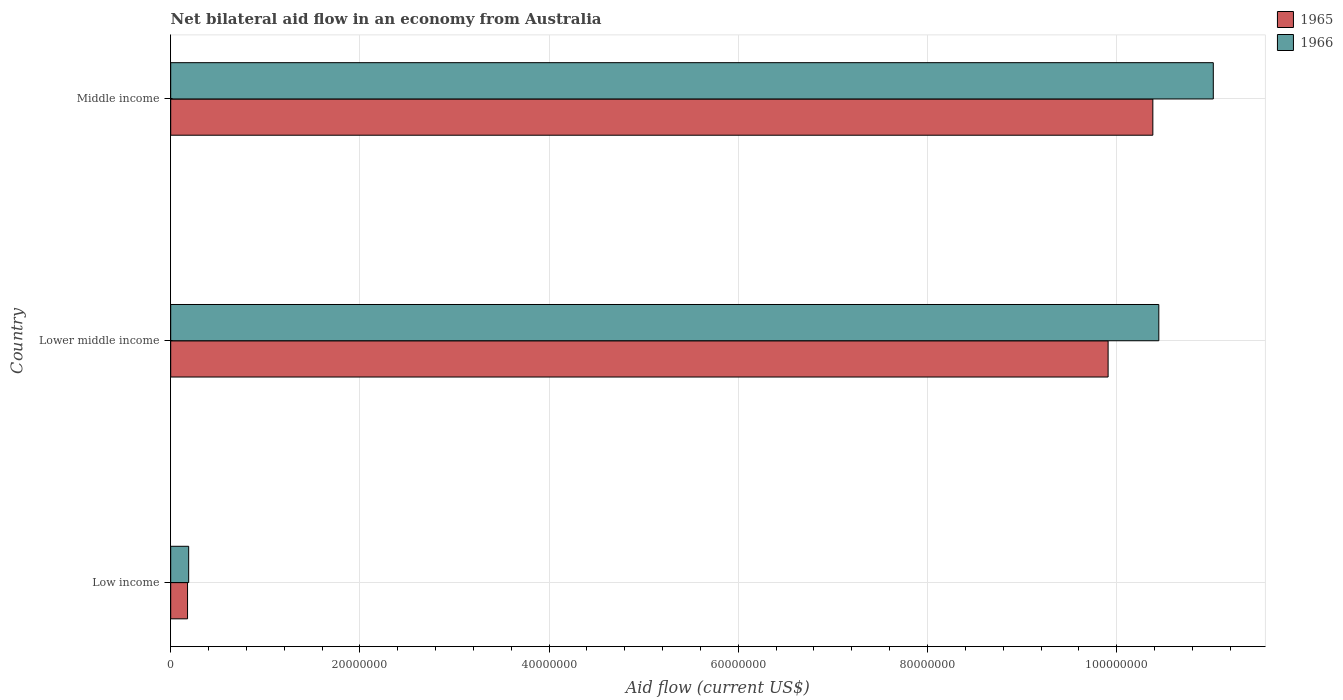How many different coloured bars are there?
Ensure brevity in your answer.  2. How many groups of bars are there?
Make the answer very short. 3. Are the number of bars on each tick of the Y-axis equal?
Make the answer very short. Yes. How many bars are there on the 3rd tick from the top?
Your response must be concise. 2. How many bars are there on the 3rd tick from the bottom?
Your response must be concise. 2. What is the label of the 3rd group of bars from the top?
Your answer should be compact. Low income. In how many cases, is the number of bars for a given country not equal to the number of legend labels?
Provide a succinct answer. 0. What is the net bilateral aid flow in 1965 in Low income?
Give a very brief answer. 1.78e+06. Across all countries, what is the maximum net bilateral aid flow in 1965?
Make the answer very short. 1.04e+08. Across all countries, what is the minimum net bilateral aid flow in 1965?
Provide a succinct answer. 1.78e+06. What is the total net bilateral aid flow in 1966 in the graph?
Your answer should be very brief. 2.17e+08. What is the difference between the net bilateral aid flow in 1965 in Low income and that in Lower middle income?
Give a very brief answer. -9.73e+07. What is the difference between the net bilateral aid flow in 1965 in Lower middle income and the net bilateral aid flow in 1966 in Middle income?
Offer a very short reply. -1.11e+07. What is the average net bilateral aid flow in 1966 per country?
Your response must be concise. 7.22e+07. What is the difference between the net bilateral aid flow in 1965 and net bilateral aid flow in 1966 in Middle income?
Give a very brief answer. -6.39e+06. What is the ratio of the net bilateral aid flow in 1966 in Lower middle income to that in Middle income?
Your answer should be compact. 0.95. Is the net bilateral aid flow in 1965 in Low income less than that in Lower middle income?
Your answer should be compact. Yes. What is the difference between the highest and the second highest net bilateral aid flow in 1965?
Ensure brevity in your answer.  4.73e+06. What is the difference between the highest and the lowest net bilateral aid flow in 1966?
Your response must be concise. 1.08e+08. In how many countries, is the net bilateral aid flow in 1966 greater than the average net bilateral aid flow in 1966 taken over all countries?
Offer a terse response. 2. Is the sum of the net bilateral aid flow in 1965 in Low income and Middle income greater than the maximum net bilateral aid flow in 1966 across all countries?
Provide a short and direct response. No. What does the 1st bar from the top in Middle income represents?
Offer a very short reply. 1966. What does the 2nd bar from the bottom in Low income represents?
Provide a short and direct response. 1966. How many countries are there in the graph?
Provide a short and direct response. 3. What is the difference between two consecutive major ticks on the X-axis?
Your answer should be very brief. 2.00e+07. Does the graph contain grids?
Ensure brevity in your answer.  Yes. Where does the legend appear in the graph?
Your answer should be compact. Top right. How many legend labels are there?
Provide a short and direct response. 2. How are the legend labels stacked?
Offer a very short reply. Vertical. What is the title of the graph?
Make the answer very short. Net bilateral aid flow in an economy from Australia. What is the label or title of the X-axis?
Provide a succinct answer. Aid flow (current US$). What is the label or title of the Y-axis?
Provide a succinct answer. Country. What is the Aid flow (current US$) in 1965 in Low income?
Provide a short and direct response. 1.78e+06. What is the Aid flow (current US$) in 1966 in Low income?
Give a very brief answer. 1.90e+06. What is the Aid flow (current US$) of 1965 in Lower middle income?
Keep it short and to the point. 9.91e+07. What is the Aid flow (current US$) of 1966 in Lower middle income?
Offer a very short reply. 1.04e+08. What is the Aid flow (current US$) of 1965 in Middle income?
Offer a terse response. 1.04e+08. What is the Aid flow (current US$) of 1966 in Middle income?
Give a very brief answer. 1.10e+08. Across all countries, what is the maximum Aid flow (current US$) in 1965?
Your answer should be compact. 1.04e+08. Across all countries, what is the maximum Aid flow (current US$) in 1966?
Your response must be concise. 1.10e+08. Across all countries, what is the minimum Aid flow (current US$) in 1965?
Your response must be concise. 1.78e+06. Across all countries, what is the minimum Aid flow (current US$) in 1966?
Offer a terse response. 1.90e+06. What is the total Aid flow (current US$) in 1965 in the graph?
Your answer should be compact. 2.05e+08. What is the total Aid flow (current US$) of 1966 in the graph?
Provide a short and direct response. 2.17e+08. What is the difference between the Aid flow (current US$) of 1965 in Low income and that in Lower middle income?
Keep it short and to the point. -9.73e+07. What is the difference between the Aid flow (current US$) of 1966 in Low income and that in Lower middle income?
Offer a very short reply. -1.03e+08. What is the difference between the Aid flow (current US$) in 1965 in Low income and that in Middle income?
Make the answer very short. -1.02e+08. What is the difference between the Aid flow (current US$) of 1966 in Low income and that in Middle income?
Ensure brevity in your answer.  -1.08e+08. What is the difference between the Aid flow (current US$) in 1965 in Lower middle income and that in Middle income?
Ensure brevity in your answer.  -4.73e+06. What is the difference between the Aid flow (current US$) of 1966 in Lower middle income and that in Middle income?
Your response must be concise. -5.76e+06. What is the difference between the Aid flow (current US$) in 1965 in Low income and the Aid flow (current US$) in 1966 in Lower middle income?
Provide a short and direct response. -1.03e+08. What is the difference between the Aid flow (current US$) in 1965 in Low income and the Aid flow (current US$) in 1966 in Middle income?
Keep it short and to the point. -1.08e+08. What is the difference between the Aid flow (current US$) in 1965 in Lower middle income and the Aid flow (current US$) in 1966 in Middle income?
Ensure brevity in your answer.  -1.11e+07. What is the average Aid flow (current US$) in 1965 per country?
Provide a succinct answer. 6.82e+07. What is the average Aid flow (current US$) in 1966 per country?
Make the answer very short. 7.22e+07. What is the difference between the Aid flow (current US$) in 1965 and Aid flow (current US$) in 1966 in Low income?
Keep it short and to the point. -1.20e+05. What is the difference between the Aid flow (current US$) of 1965 and Aid flow (current US$) of 1966 in Lower middle income?
Ensure brevity in your answer.  -5.36e+06. What is the difference between the Aid flow (current US$) of 1965 and Aid flow (current US$) of 1966 in Middle income?
Offer a very short reply. -6.39e+06. What is the ratio of the Aid flow (current US$) of 1965 in Low income to that in Lower middle income?
Ensure brevity in your answer.  0.02. What is the ratio of the Aid flow (current US$) of 1966 in Low income to that in Lower middle income?
Give a very brief answer. 0.02. What is the ratio of the Aid flow (current US$) of 1965 in Low income to that in Middle income?
Your answer should be very brief. 0.02. What is the ratio of the Aid flow (current US$) of 1966 in Low income to that in Middle income?
Ensure brevity in your answer.  0.02. What is the ratio of the Aid flow (current US$) of 1965 in Lower middle income to that in Middle income?
Offer a terse response. 0.95. What is the ratio of the Aid flow (current US$) in 1966 in Lower middle income to that in Middle income?
Offer a terse response. 0.95. What is the difference between the highest and the second highest Aid flow (current US$) in 1965?
Offer a terse response. 4.73e+06. What is the difference between the highest and the second highest Aid flow (current US$) of 1966?
Provide a short and direct response. 5.76e+06. What is the difference between the highest and the lowest Aid flow (current US$) in 1965?
Offer a very short reply. 1.02e+08. What is the difference between the highest and the lowest Aid flow (current US$) of 1966?
Provide a short and direct response. 1.08e+08. 